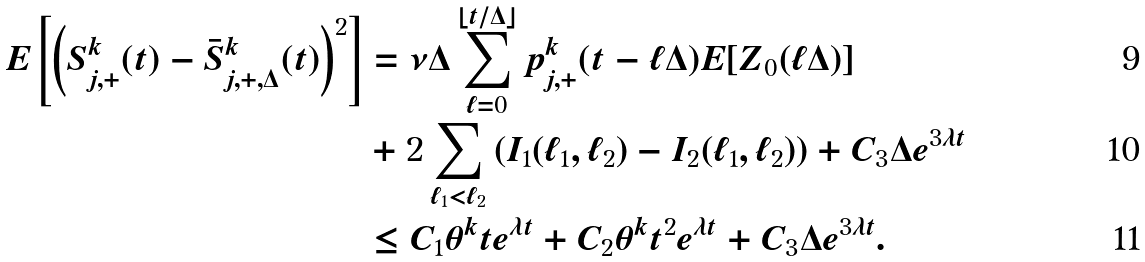<formula> <loc_0><loc_0><loc_500><loc_500>E \left [ \left ( S ^ { k } _ { j , + } ( t ) - \bar { S } ^ { k } _ { j , + , \Delta } ( t ) \right ) ^ { 2 } \right ] & = \nu \Delta \sum _ { \ell = 0 } ^ { \lfloor t / \Delta \rfloor } p ^ { k } _ { j , + } ( t - \ell \Delta ) E [ Z _ { 0 } ( \ell \Delta ) ] \\ & + 2 \sum _ { \ell _ { 1 } < \ell _ { 2 } } \left ( I _ { 1 } ( \ell _ { 1 } , \ell _ { 2 } ) - I _ { 2 } ( \ell _ { 1 } , \ell _ { 2 } ) \right ) + C _ { 3 } \Delta e ^ { 3 \lambda t } \\ & \leq C _ { 1 } \theta ^ { k } t e ^ { \lambda t } + C _ { 2 } \theta ^ { k } t ^ { 2 } e ^ { \lambda t } + C _ { 3 } \Delta e ^ { 3 \lambda t } .</formula> 